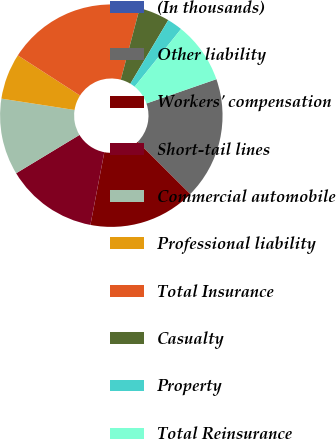Convert chart to OTSL. <chart><loc_0><loc_0><loc_500><loc_500><pie_chart><fcel>(In thousands)<fcel>Other liability<fcel>Workers' compensation<fcel>Short-tail lines<fcel>Commercial automobile<fcel>Professional liability<fcel>Total Insurance<fcel>Casualty<fcel>Property<fcel>Total Reinsurance<nl><fcel>0.01%<fcel>17.77%<fcel>15.55%<fcel>13.33%<fcel>11.11%<fcel>6.67%<fcel>19.99%<fcel>4.45%<fcel>2.23%<fcel>8.89%<nl></chart> 